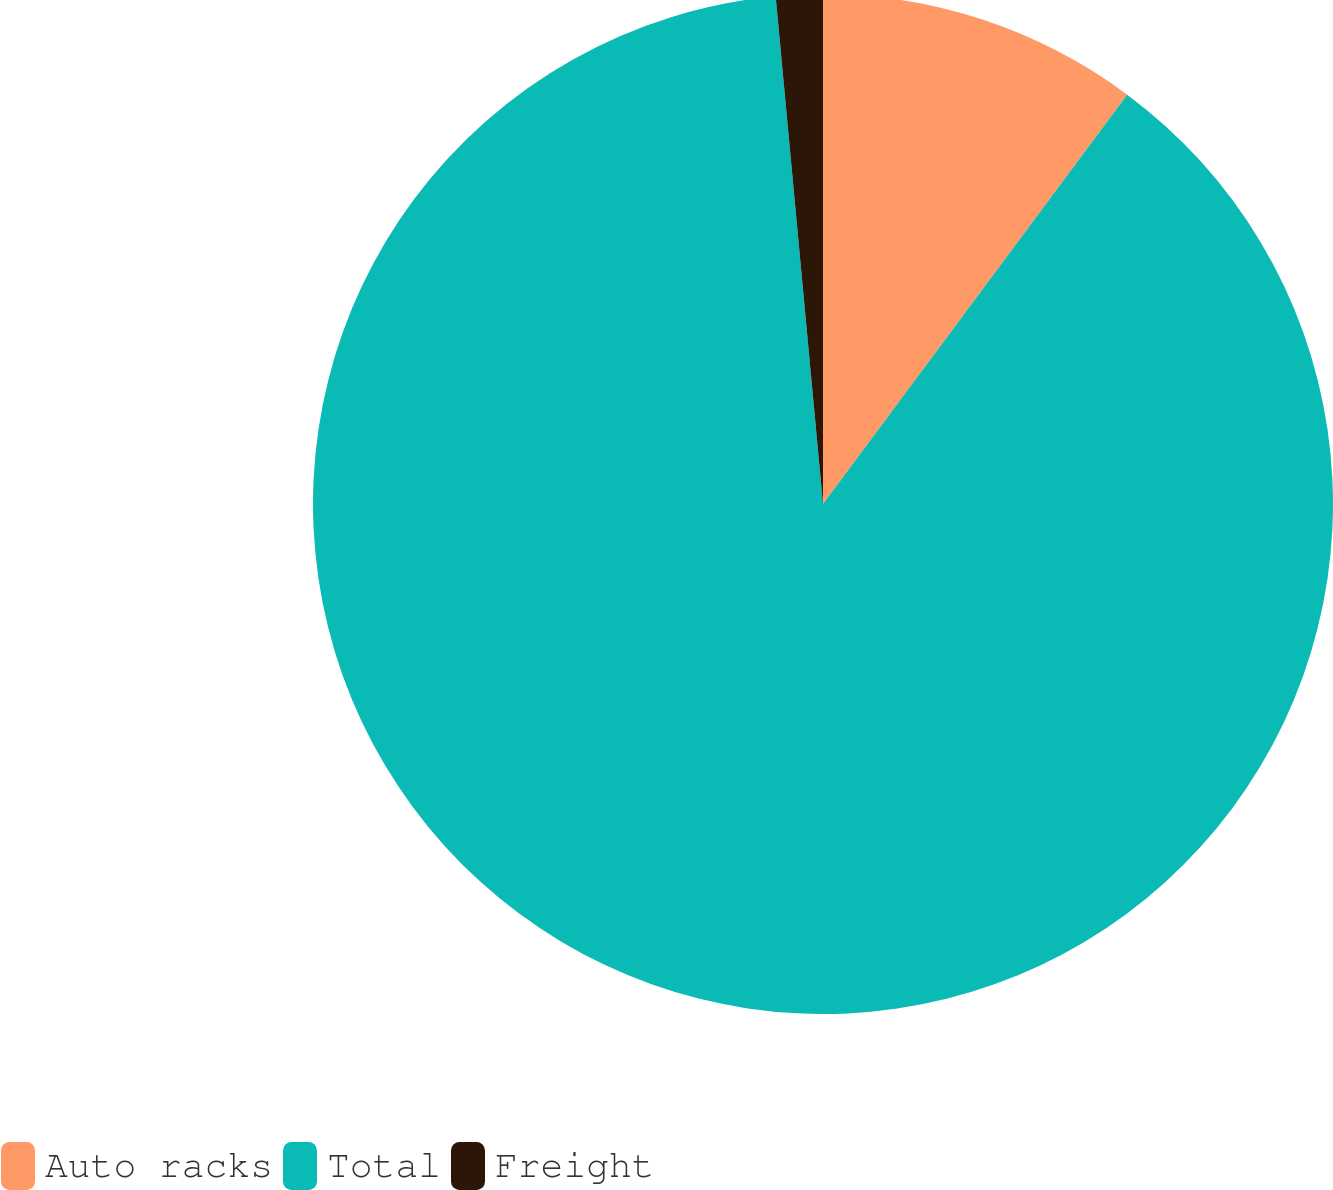Convert chart to OTSL. <chart><loc_0><loc_0><loc_500><loc_500><pie_chart><fcel>Auto racks<fcel>Total<fcel>Freight<nl><fcel>10.17%<fcel>88.35%<fcel>1.48%<nl></chart> 